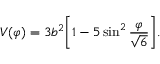<formula> <loc_0><loc_0><loc_500><loc_500>V ( \varphi ) = 3 b ^ { 2 } \left [ 1 - 5 \sin ^ { 2 } \frac { \varphi } { \sqrt { 6 } } \right ] .</formula> 